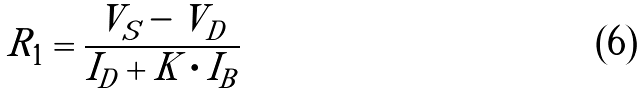<formula> <loc_0><loc_0><loc_500><loc_500>R _ { 1 } = \frac { V _ { S } - V _ { D } } { I _ { D } + K \cdot I _ { B } }</formula> 